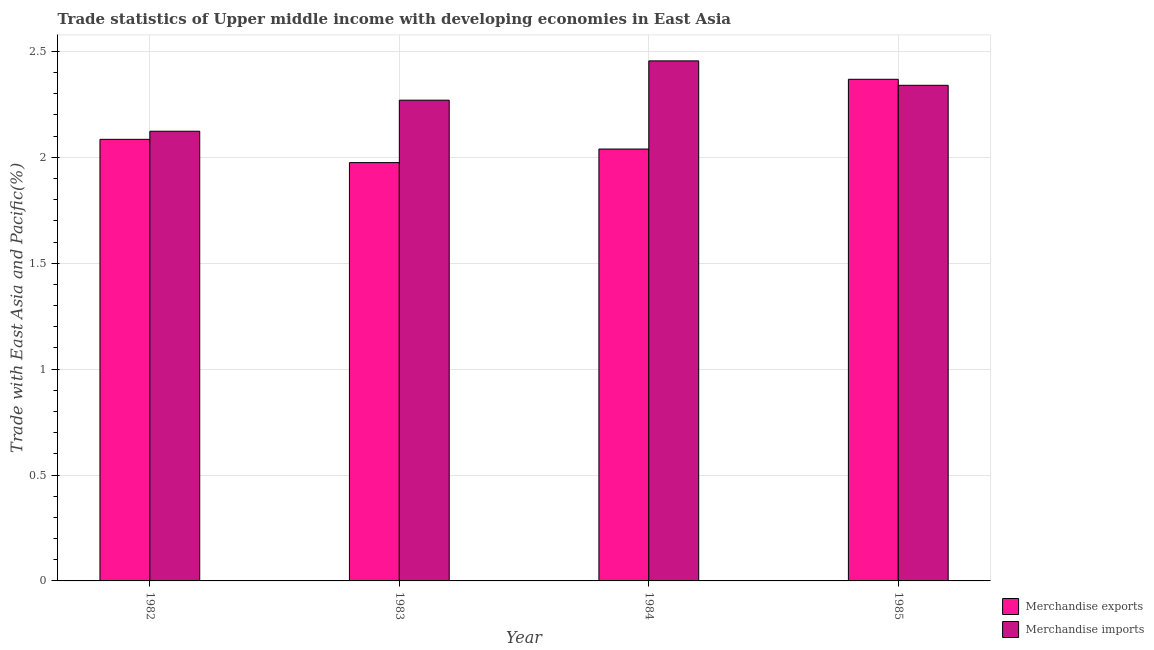Are the number of bars on each tick of the X-axis equal?
Keep it short and to the point. Yes. How many bars are there on the 2nd tick from the left?
Offer a terse response. 2. What is the label of the 3rd group of bars from the left?
Your response must be concise. 1984. In how many cases, is the number of bars for a given year not equal to the number of legend labels?
Ensure brevity in your answer.  0. What is the merchandise imports in 1982?
Offer a very short reply. 2.12. Across all years, what is the maximum merchandise imports?
Provide a short and direct response. 2.46. Across all years, what is the minimum merchandise exports?
Your response must be concise. 1.98. What is the total merchandise exports in the graph?
Offer a terse response. 8.47. What is the difference between the merchandise exports in 1984 and that in 1985?
Keep it short and to the point. -0.33. What is the difference between the merchandise exports in 1982 and the merchandise imports in 1983?
Your answer should be very brief. 0.11. What is the average merchandise imports per year?
Your answer should be compact. 2.3. In the year 1985, what is the difference between the merchandise imports and merchandise exports?
Provide a succinct answer. 0. What is the ratio of the merchandise imports in 1982 to that in 1984?
Your response must be concise. 0.86. Is the merchandise exports in 1982 less than that in 1983?
Keep it short and to the point. No. Is the difference between the merchandise imports in 1983 and 1984 greater than the difference between the merchandise exports in 1983 and 1984?
Your answer should be very brief. No. What is the difference between the highest and the second highest merchandise imports?
Give a very brief answer. 0.12. What is the difference between the highest and the lowest merchandise imports?
Your answer should be compact. 0.33. In how many years, is the merchandise imports greater than the average merchandise imports taken over all years?
Offer a very short reply. 2. Is the sum of the merchandise imports in 1983 and 1985 greater than the maximum merchandise exports across all years?
Your response must be concise. Yes. What does the 2nd bar from the left in 1983 represents?
Your answer should be very brief. Merchandise imports. What does the 2nd bar from the right in 1983 represents?
Provide a succinct answer. Merchandise exports. Are all the bars in the graph horizontal?
Your response must be concise. No. How many years are there in the graph?
Your answer should be compact. 4. Does the graph contain any zero values?
Your answer should be very brief. No. Does the graph contain grids?
Provide a short and direct response. Yes. Where does the legend appear in the graph?
Provide a succinct answer. Bottom right. How many legend labels are there?
Make the answer very short. 2. How are the legend labels stacked?
Your response must be concise. Vertical. What is the title of the graph?
Your answer should be compact. Trade statistics of Upper middle income with developing economies in East Asia. What is the label or title of the X-axis?
Provide a short and direct response. Year. What is the label or title of the Y-axis?
Make the answer very short. Trade with East Asia and Pacific(%). What is the Trade with East Asia and Pacific(%) in Merchandise exports in 1982?
Keep it short and to the point. 2.08. What is the Trade with East Asia and Pacific(%) of Merchandise imports in 1982?
Your answer should be very brief. 2.12. What is the Trade with East Asia and Pacific(%) in Merchandise exports in 1983?
Keep it short and to the point. 1.98. What is the Trade with East Asia and Pacific(%) of Merchandise imports in 1983?
Provide a short and direct response. 2.27. What is the Trade with East Asia and Pacific(%) in Merchandise exports in 1984?
Provide a succinct answer. 2.04. What is the Trade with East Asia and Pacific(%) in Merchandise imports in 1984?
Give a very brief answer. 2.46. What is the Trade with East Asia and Pacific(%) in Merchandise exports in 1985?
Offer a very short reply. 2.37. What is the Trade with East Asia and Pacific(%) in Merchandise imports in 1985?
Provide a succinct answer. 2.34. Across all years, what is the maximum Trade with East Asia and Pacific(%) of Merchandise exports?
Give a very brief answer. 2.37. Across all years, what is the maximum Trade with East Asia and Pacific(%) of Merchandise imports?
Ensure brevity in your answer.  2.46. Across all years, what is the minimum Trade with East Asia and Pacific(%) of Merchandise exports?
Provide a short and direct response. 1.98. Across all years, what is the minimum Trade with East Asia and Pacific(%) of Merchandise imports?
Provide a short and direct response. 2.12. What is the total Trade with East Asia and Pacific(%) in Merchandise exports in the graph?
Ensure brevity in your answer.  8.47. What is the total Trade with East Asia and Pacific(%) of Merchandise imports in the graph?
Keep it short and to the point. 9.19. What is the difference between the Trade with East Asia and Pacific(%) in Merchandise exports in 1982 and that in 1983?
Your answer should be very brief. 0.11. What is the difference between the Trade with East Asia and Pacific(%) of Merchandise imports in 1982 and that in 1983?
Your answer should be very brief. -0.15. What is the difference between the Trade with East Asia and Pacific(%) in Merchandise exports in 1982 and that in 1984?
Your answer should be very brief. 0.05. What is the difference between the Trade with East Asia and Pacific(%) in Merchandise imports in 1982 and that in 1984?
Keep it short and to the point. -0.33. What is the difference between the Trade with East Asia and Pacific(%) in Merchandise exports in 1982 and that in 1985?
Ensure brevity in your answer.  -0.28. What is the difference between the Trade with East Asia and Pacific(%) in Merchandise imports in 1982 and that in 1985?
Make the answer very short. -0.22. What is the difference between the Trade with East Asia and Pacific(%) in Merchandise exports in 1983 and that in 1984?
Give a very brief answer. -0.06. What is the difference between the Trade with East Asia and Pacific(%) in Merchandise imports in 1983 and that in 1984?
Your answer should be very brief. -0.19. What is the difference between the Trade with East Asia and Pacific(%) of Merchandise exports in 1983 and that in 1985?
Provide a short and direct response. -0.39. What is the difference between the Trade with East Asia and Pacific(%) in Merchandise imports in 1983 and that in 1985?
Give a very brief answer. -0.07. What is the difference between the Trade with East Asia and Pacific(%) in Merchandise exports in 1984 and that in 1985?
Provide a short and direct response. -0.33. What is the difference between the Trade with East Asia and Pacific(%) of Merchandise imports in 1984 and that in 1985?
Provide a succinct answer. 0.12. What is the difference between the Trade with East Asia and Pacific(%) of Merchandise exports in 1982 and the Trade with East Asia and Pacific(%) of Merchandise imports in 1983?
Make the answer very short. -0.18. What is the difference between the Trade with East Asia and Pacific(%) in Merchandise exports in 1982 and the Trade with East Asia and Pacific(%) in Merchandise imports in 1984?
Make the answer very short. -0.37. What is the difference between the Trade with East Asia and Pacific(%) in Merchandise exports in 1982 and the Trade with East Asia and Pacific(%) in Merchandise imports in 1985?
Your answer should be very brief. -0.26. What is the difference between the Trade with East Asia and Pacific(%) in Merchandise exports in 1983 and the Trade with East Asia and Pacific(%) in Merchandise imports in 1984?
Ensure brevity in your answer.  -0.48. What is the difference between the Trade with East Asia and Pacific(%) of Merchandise exports in 1983 and the Trade with East Asia and Pacific(%) of Merchandise imports in 1985?
Give a very brief answer. -0.36. What is the difference between the Trade with East Asia and Pacific(%) in Merchandise exports in 1984 and the Trade with East Asia and Pacific(%) in Merchandise imports in 1985?
Your response must be concise. -0.3. What is the average Trade with East Asia and Pacific(%) of Merchandise exports per year?
Provide a short and direct response. 2.12. What is the average Trade with East Asia and Pacific(%) of Merchandise imports per year?
Keep it short and to the point. 2.3. In the year 1982, what is the difference between the Trade with East Asia and Pacific(%) of Merchandise exports and Trade with East Asia and Pacific(%) of Merchandise imports?
Offer a terse response. -0.04. In the year 1983, what is the difference between the Trade with East Asia and Pacific(%) in Merchandise exports and Trade with East Asia and Pacific(%) in Merchandise imports?
Ensure brevity in your answer.  -0.29. In the year 1984, what is the difference between the Trade with East Asia and Pacific(%) in Merchandise exports and Trade with East Asia and Pacific(%) in Merchandise imports?
Make the answer very short. -0.42. In the year 1985, what is the difference between the Trade with East Asia and Pacific(%) in Merchandise exports and Trade with East Asia and Pacific(%) in Merchandise imports?
Provide a succinct answer. 0.03. What is the ratio of the Trade with East Asia and Pacific(%) in Merchandise exports in 1982 to that in 1983?
Give a very brief answer. 1.06. What is the ratio of the Trade with East Asia and Pacific(%) in Merchandise imports in 1982 to that in 1983?
Ensure brevity in your answer.  0.94. What is the ratio of the Trade with East Asia and Pacific(%) in Merchandise exports in 1982 to that in 1984?
Offer a terse response. 1.02. What is the ratio of the Trade with East Asia and Pacific(%) of Merchandise imports in 1982 to that in 1984?
Make the answer very short. 0.86. What is the ratio of the Trade with East Asia and Pacific(%) of Merchandise exports in 1982 to that in 1985?
Your answer should be very brief. 0.88. What is the ratio of the Trade with East Asia and Pacific(%) in Merchandise imports in 1982 to that in 1985?
Keep it short and to the point. 0.91. What is the ratio of the Trade with East Asia and Pacific(%) in Merchandise exports in 1983 to that in 1984?
Provide a succinct answer. 0.97. What is the ratio of the Trade with East Asia and Pacific(%) in Merchandise imports in 1983 to that in 1984?
Offer a terse response. 0.92. What is the ratio of the Trade with East Asia and Pacific(%) of Merchandise exports in 1983 to that in 1985?
Your response must be concise. 0.83. What is the ratio of the Trade with East Asia and Pacific(%) of Merchandise imports in 1983 to that in 1985?
Your response must be concise. 0.97. What is the ratio of the Trade with East Asia and Pacific(%) in Merchandise exports in 1984 to that in 1985?
Your answer should be very brief. 0.86. What is the ratio of the Trade with East Asia and Pacific(%) in Merchandise imports in 1984 to that in 1985?
Your answer should be very brief. 1.05. What is the difference between the highest and the second highest Trade with East Asia and Pacific(%) of Merchandise exports?
Your answer should be very brief. 0.28. What is the difference between the highest and the second highest Trade with East Asia and Pacific(%) of Merchandise imports?
Provide a short and direct response. 0.12. What is the difference between the highest and the lowest Trade with East Asia and Pacific(%) in Merchandise exports?
Your answer should be very brief. 0.39. What is the difference between the highest and the lowest Trade with East Asia and Pacific(%) in Merchandise imports?
Offer a very short reply. 0.33. 